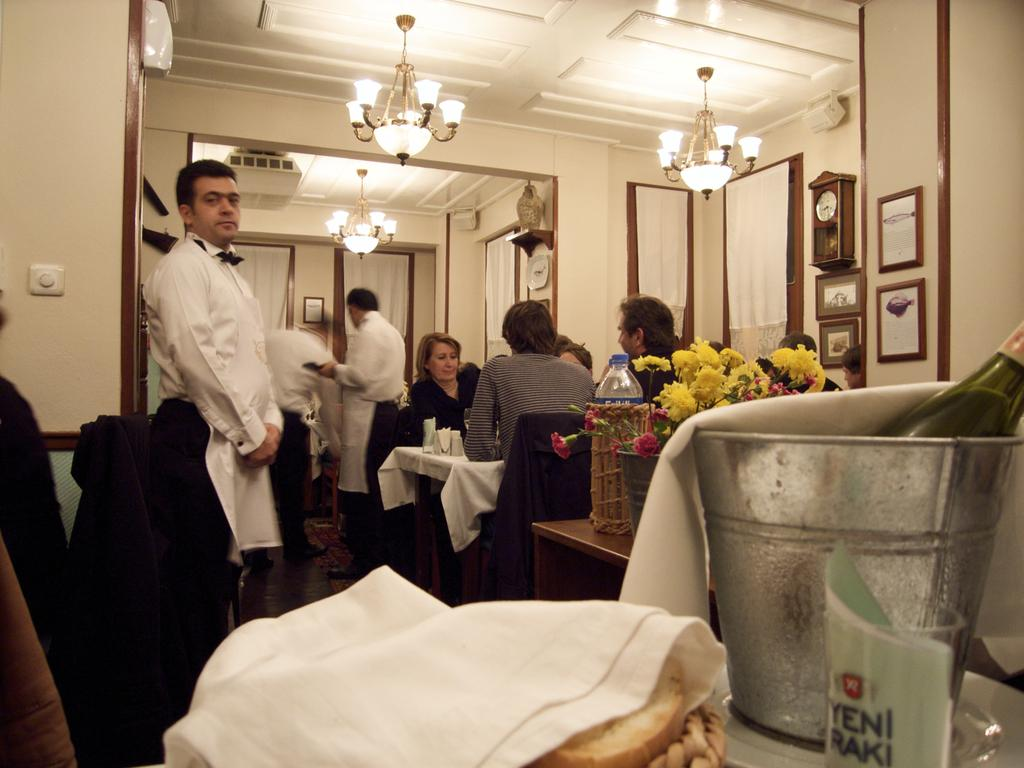What are the people in the image doing? There are people standing and seated on chairs in the image. What type of lighting is present in the image? There are chandelier lights visible in the image. What division is being discussed in the image? There is no indication of a division being discussed in the image; it primarily features people and chandelier lights. 